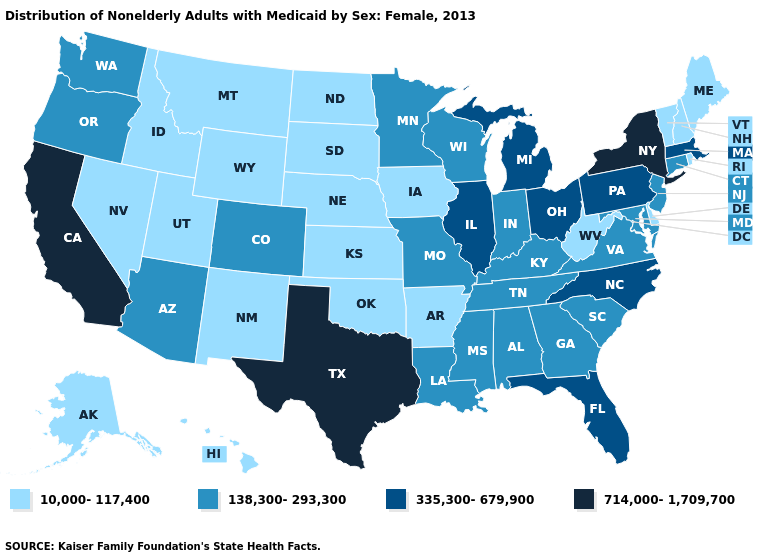Does the map have missing data?
Write a very short answer. No. What is the value of Indiana?
Short answer required. 138,300-293,300. Does Texas have the highest value in the USA?
Keep it brief. Yes. What is the highest value in the West ?
Concise answer only. 714,000-1,709,700. Which states have the lowest value in the USA?
Be succinct. Alaska, Arkansas, Delaware, Hawaii, Idaho, Iowa, Kansas, Maine, Montana, Nebraska, Nevada, New Hampshire, New Mexico, North Dakota, Oklahoma, Rhode Island, South Dakota, Utah, Vermont, West Virginia, Wyoming. Name the states that have a value in the range 714,000-1,709,700?
Keep it brief. California, New York, Texas. Name the states that have a value in the range 138,300-293,300?
Answer briefly. Alabama, Arizona, Colorado, Connecticut, Georgia, Indiana, Kentucky, Louisiana, Maryland, Minnesota, Mississippi, Missouri, New Jersey, Oregon, South Carolina, Tennessee, Virginia, Washington, Wisconsin. Which states have the highest value in the USA?
Quick response, please. California, New York, Texas. Name the states that have a value in the range 335,300-679,900?
Answer briefly. Florida, Illinois, Massachusetts, Michigan, North Carolina, Ohio, Pennsylvania. Does the map have missing data?
Concise answer only. No. What is the value of Kentucky?
Concise answer only. 138,300-293,300. Does Alabama have the highest value in the USA?
Answer briefly. No. Is the legend a continuous bar?
Short answer required. No. What is the value of South Dakota?
Be succinct. 10,000-117,400. What is the value of New Jersey?
Concise answer only. 138,300-293,300. 